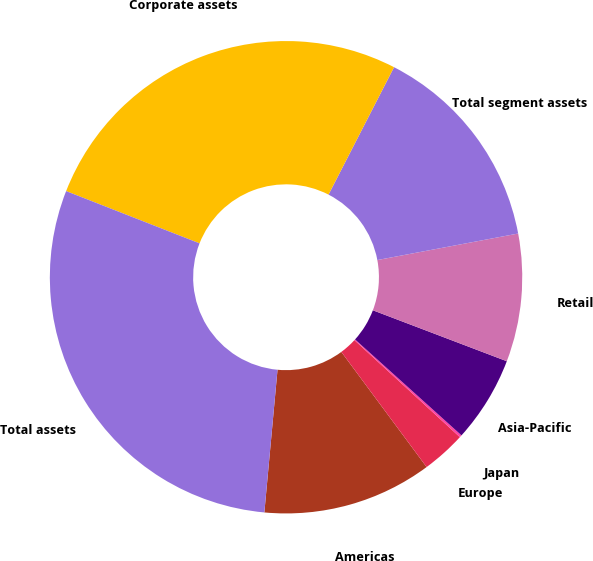Convert chart to OTSL. <chart><loc_0><loc_0><loc_500><loc_500><pie_chart><fcel>Americas<fcel>Europe<fcel>Japan<fcel>Asia-Pacific<fcel>Retail<fcel>Total segment assets<fcel>Corporate assets<fcel>Total assets<nl><fcel>11.61%<fcel>3.02%<fcel>0.16%<fcel>5.89%<fcel>8.75%<fcel>14.48%<fcel>26.62%<fcel>29.48%<nl></chart> 